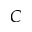<formula> <loc_0><loc_0><loc_500><loc_500>C</formula> 